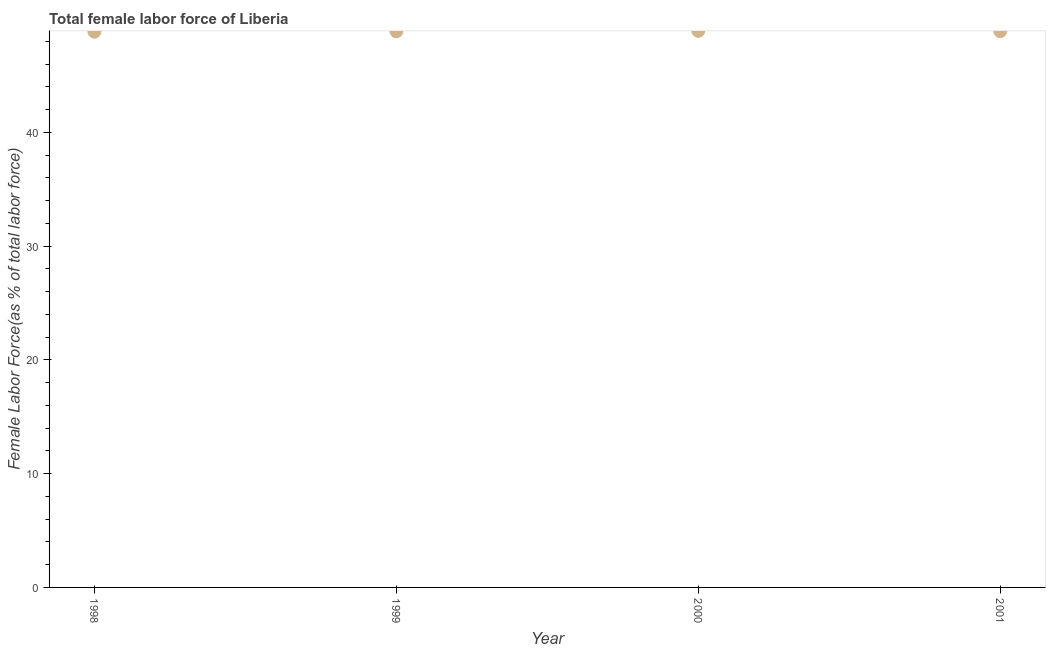What is the total female labor force in 2001?
Provide a short and direct response. 48.89. Across all years, what is the maximum total female labor force?
Offer a very short reply. 48.92. Across all years, what is the minimum total female labor force?
Provide a short and direct response. 48.84. In which year was the total female labor force maximum?
Offer a very short reply. 2000. In which year was the total female labor force minimum?
Your response must be concise. 1998. What is the sum of the total female labor force?
Your response must be concise. 195.52. What is the difference between the total female labor force in 1998 and 2000?
Provide a short and direct response. -0.07. What is the average total female labor force per year?
Your answer should be very brief. 48.88. What is the median total female labor force?
Offer a very short reply. 48.88. Do a majority of the years between 2001 and 1999 (inclusive) have total female labor force greater than 18 %?
Provide a succinct answer. No. What is the ratio of the total female labor force in 2000 to that in 2001?
Your answer should be very brief. 1. What is the difference between the highest and the second highest total female labor force?
Your answer should be compact. 0.03. What is the difference between the highest and the lowest total female labor force?
Your answer should be very brief. 0.07. In how many years, is the total female labor force greater than the average total female labor force taken over all years?
Keep it short and to the point. 2. How many dotlines are there?
Your answer should be compact. 1. How many years are there in the graph?
Offer a terse response. 4. What is the title of the graph?
Offer a very short reply. Total female labor force of Liberia. What is the label or title of the Y-axis?
Provide a short and direct response. Female Labor Force(as % of total labor force). What is the Female Labor Force(as % of total labor force) in 1998?
Keep it short and to the point. 48.84. What is the Female Labor Force(as % of total labor force) in 1999?
Your answer should be compact. 48.88. What is the Female Labor Force(as % of total labor force) in 2000?
Make the answer very short. 48.92. What is the Female Labor Force(as % of total labor force) in 2001?
Your answer should be very brief. 48.89. What is the difference between the Female Labor Force(as % of total labor force) in 1998 and 1999?
Keep it short and to the point. -0.03. What is the difference between the Female Labor Force(as % of total labor force) in 1998 and 2000?
Provide a succinct answer. -0.07. What is the difference between the Female Labor Force(as % of total labor force) in 1998 and 2001?
Make the answer very short. -0.05. What is the difference between the Female Labor Force(as % of total labor force) in 1999 and 2000?
Make the answer very short. -0.04. What is the difference between the Female Labor Force(as % of total labor force) in 1999 and 2001?
Give a very brief answer. -0.01. What is the difference between the Female Labor Force(as % of total labor force) in 2000 and 2001?
Provide a short and direct response. 0.03. What is the ratio of the Female Labor Force(as % of total labor force) in 1998 to that in 1999?
Keep it short and to the point. 1. What is the ratio of the Female Labor Force(as % of total labor force) in 2000 to that in 2001?
Your answer should be very brief. 1. 